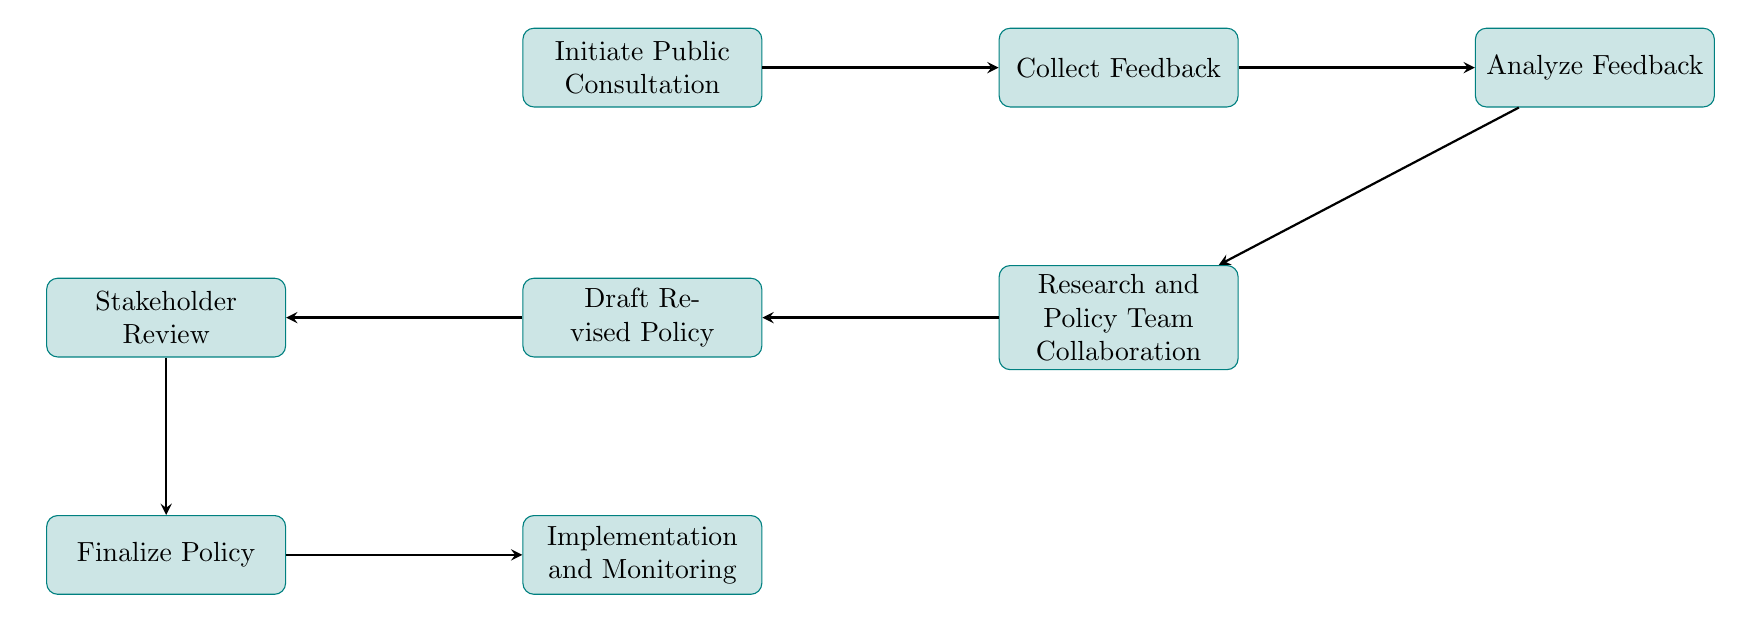What is the first step in the process? The first step is represented by the node labeled "Initiate Public Consultation," which indicates the launch of the process.
Answer: Initiate Public Consultation How many steps are there in total? Counting all the nodes from initiation to implementation, there are eight distinct steps in total represented in the diagram.
Answer: Eight What action follows "Collect Feedback"? The next action after "Collect Feedback" is "Analyze Feedback," showing that feedback is reviewed subsequently.
Answer: Analyze Feedback What is the relationship between "Stakeholder Review" and "Finalize Policy"? "Stakeholder Review" is a precursor to "Finalize Policy," indicating that stakeholder input is considered before finalizing the policy.
Answer: Preceding Which step involves collaboration between the research and policy team? The step involving collaboration is labeled "Research and Policy Team Collaboration," where the policy advisor and researcher work together.
Answer: Research and Policy Team Collaboration What do we do after drafting the revised policy? After drafting the revised policy, the next step is "Stakeholder Review," where the draft is presented for additional feedback.
Answer: Stakeholder Review What represents the final phase of the process? The final phase of the process is denoted by "Implementation and Monitoring," which consists of executing the finalized policy and observing its outcomes.
Answer: Implementation and Monitoring How does the process transition from "Analyze Feedback" to "Research and Policy Team Collaboration"? There is a direct arrow indicating a one-way flow from "Analyze Feedback" to "Research and Policy Team Collaboration," signifying that analyzing feedback leads to collaboration on the policy changes.
Answer: One-way flow 